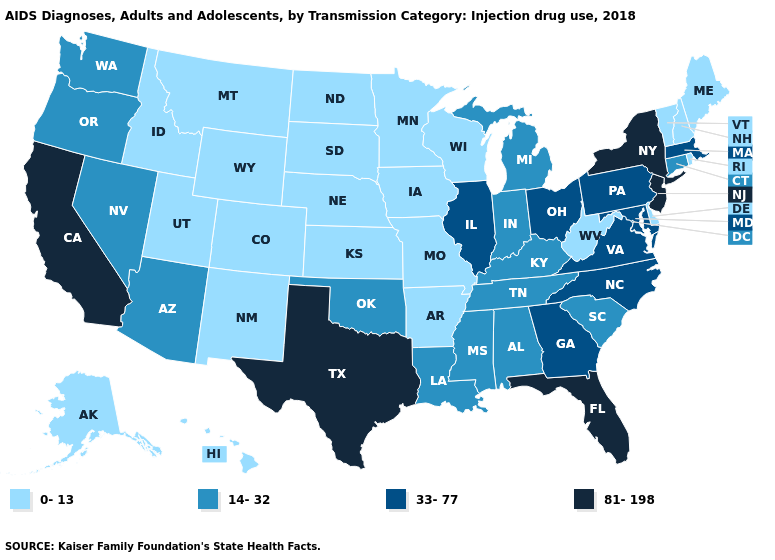Among the states that border Alabama , which have the lowest value?
Short answer required. Mississippi, Tennessee. Name the states that have a value in the range 81-198?
Concise answer only. California, Florida, New Jersey, New York, Texas. Name the states that have a value in the range 0-13?
Short answer required. Alaska, Arkansas, Colorado, Delaware, Hawaii, Idaho, Iowa, Kansas, Maine, Minnesota, Missouri, Montana, Nebraska, New Hampshire, New Mexico, North Dakota, Rhode Island, South Dakota, Utah, Vermont, West Virginia, Wisconsin, Wyoming. Does Oklahoma have a higher value than New York?
Concise answer only. No. Does Nevada have the highest value in the West?
Answer briefly. No. Does Maryland have the same value as Georgia?
Answer briefly. Yes. Which states hav the highest value in the Northeast?
Be succinct. New Jersey, New York. What is the highest value in states that border Oregon?
Give a very brief answer. 81-198. Does Kentucky have the highest value in the USA?
Quick response, please. No. Name the states that have a value in the range 0-13?
Short answer required. Alaska, Arkansas, Colorado, Delaware, Hawaii, Idaho, Iowa, Kansas, Maine, Minnesota, Missouri, Montana, Nebraska, New Hampshire, New Mexico, North Dakota, Rhode Island, South Dakota, Utah, Vermont, West Virginia, Wisconsin, Wyoming. Name the states that have a value in the range 14-32?
Concise answer only. Alabama, Arizona, Connecticut, Indiana, Kentucky, Louisiana, Michigan, Mississippi, Nevada, Oklahoma, Oregon, South Carolina, Tennessee, Washington. Among the states that border Vermont , which have the highest value?
Short answer required. New York. Which states have the highest value in the USA?
Concise answer only. California, Florida, New Jersey, New York, Texas. Is the legend a continuous bar?
Write a very short answer. No. Name the states that have a value in the range 33-77?
Write a very short answer. Georgia, Illinois, Maryland, Massachusetts, North Carolina, Ohio, Pennsylvania, Virginia. 